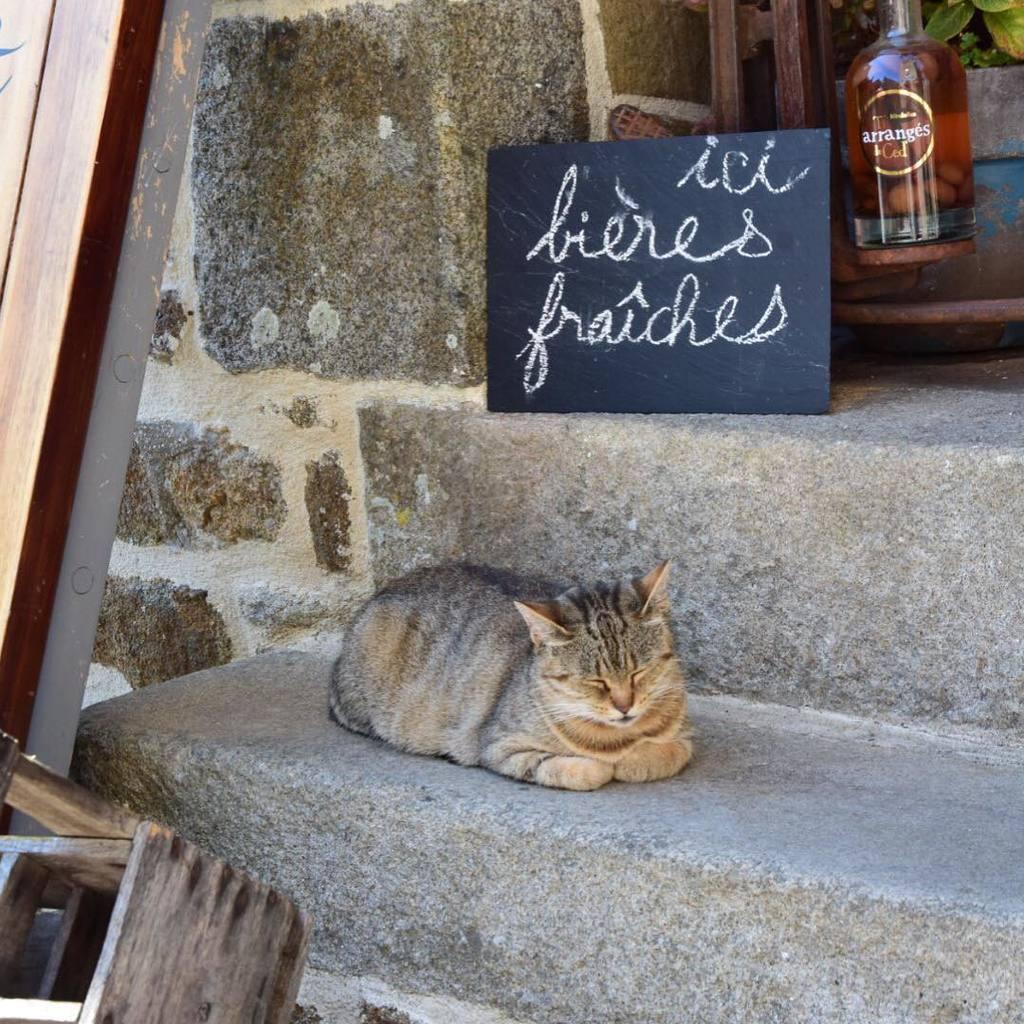Please provide a concise description of this image. This image consists of a cat sleeping on the steps. Above which there is a board and a bottle. To the left, there is a wooden bed. In the background, there is a wall made up of rocks. 